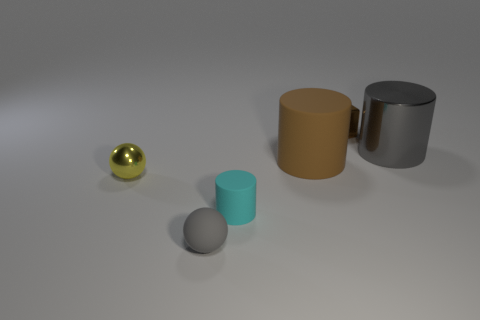Add 3 tiny cyan matte objects. How many objects exist? 9 Subtract all balls. How many objects are left? 4 Add 4 gray rubber balls. How many gray rubber balls are left? 5 Add 6 big blue blocks. How many big blue blocks exist? 6 Subtract 0 blue balls. How many objects are left? 6 Subtract all large gray metallic cylinders. Subtract all small brown blocks. How many objects are left? 4 